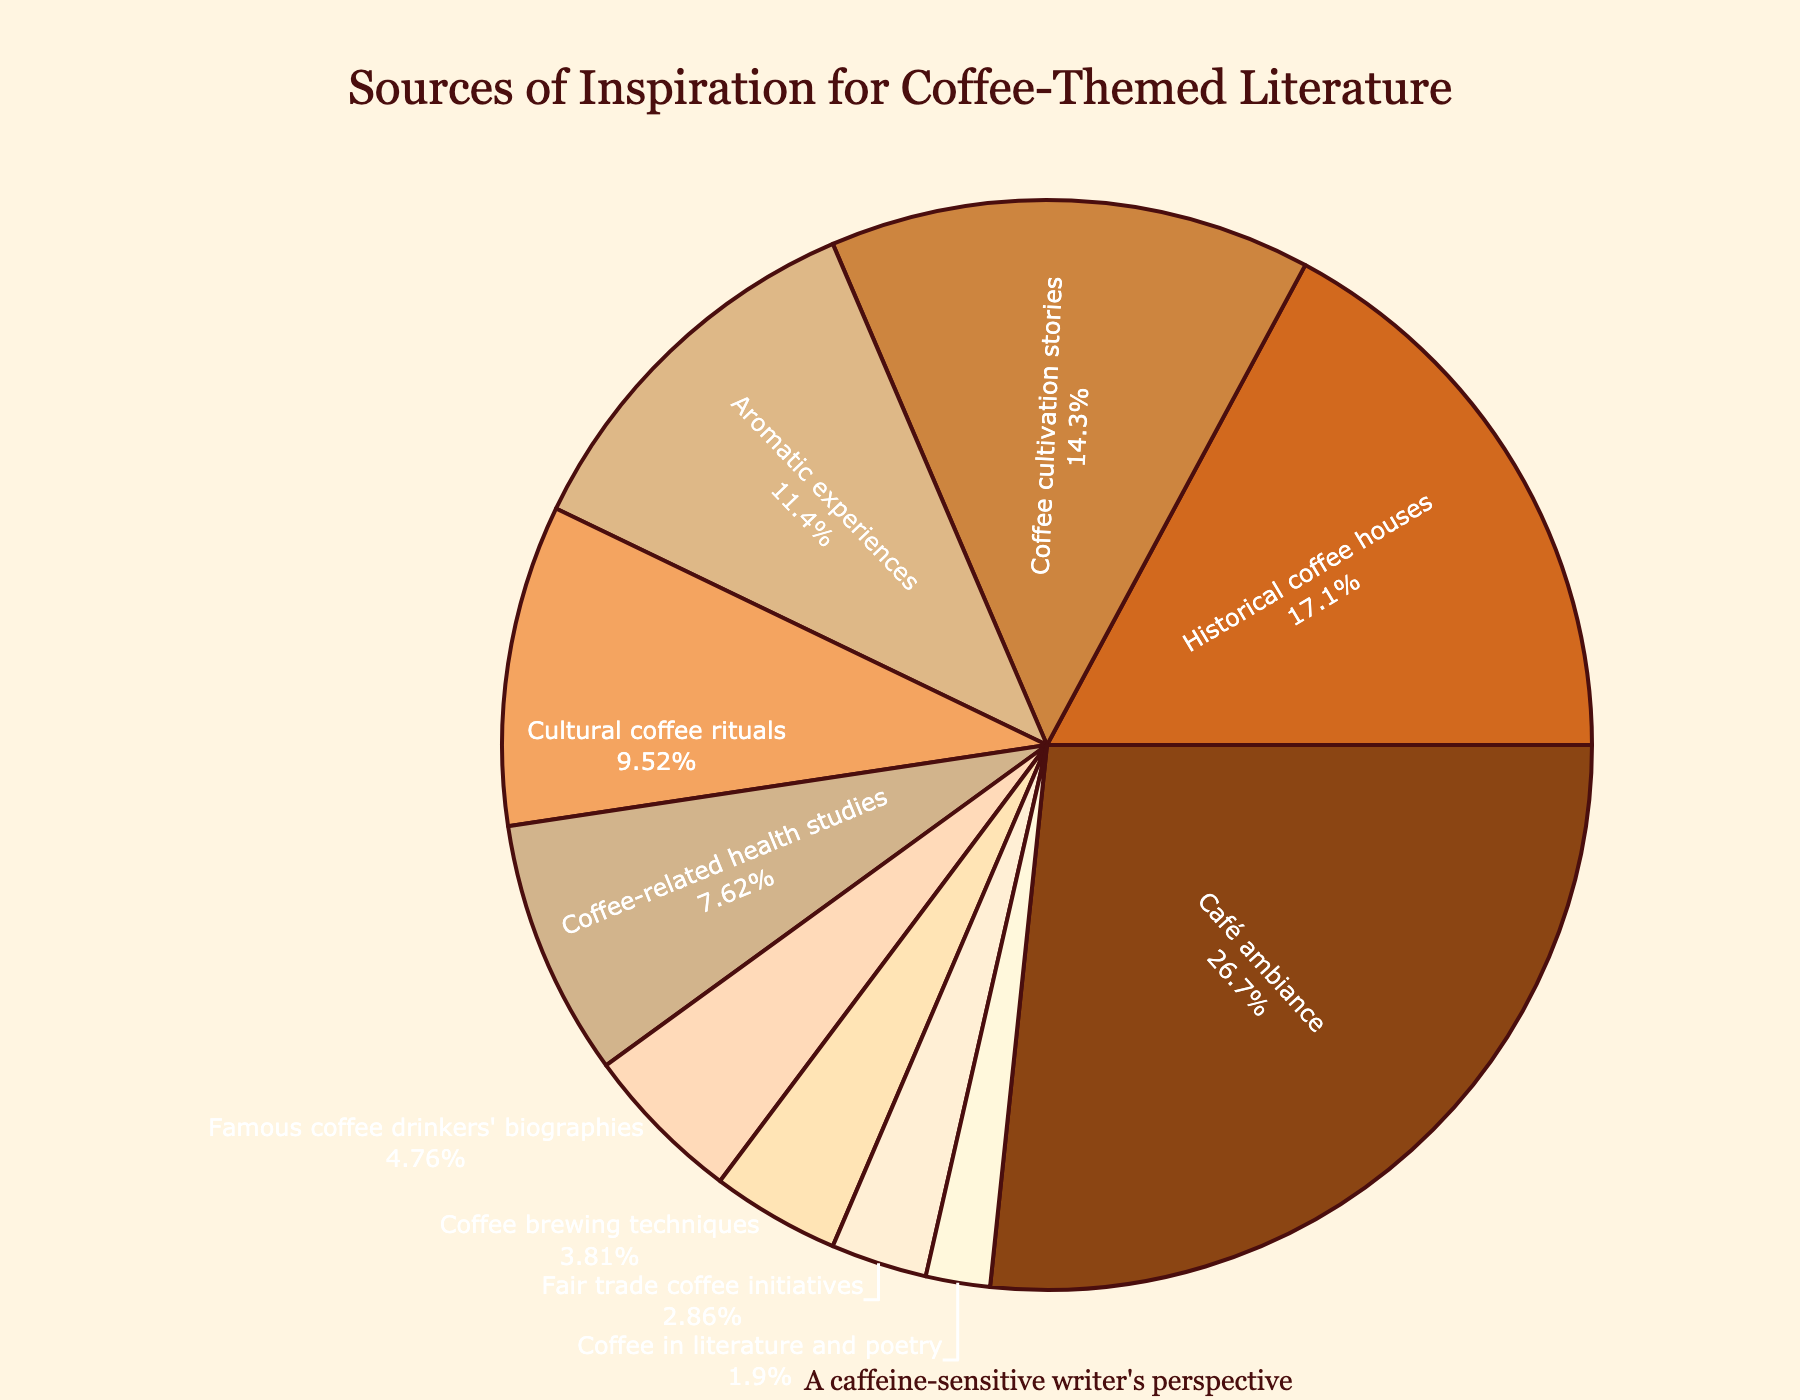What is the source with the highest percentage of inspiration? Identify the largest segment in the pie chart, which visually represents the largest percentage. The Café ambiance section is the largest segment.
Answer: Café ambiance What are the three smallest sources of inspiration? Identify the three smallest segments in the pie chart, judged by the smallest percentages. These segments are Fair trade coffee initiatives, Coffee in literature and poetry, and Coffee brewing techniques.
Answer: Fair trade coffee initiatives, Coffee in literature and poetry, Coffee brewing techniques What's the combined percentage of Cultural coffee rituals and Coffee-related health studies? Look at the percentages for Cultural coffee rituals (10%) and Coffee-related health studies (8%), and add them together. 10% + 8% = 18%
Answer: 18% How much larger is the percentage of Café ambiance compared to Aromatic experiences? Find the difference between the café ambiance (28%) and aromatic experiences (12%) by subtracting the smaller percentage from the larger one. 28% - 12% = 16%
Answer: 16% Which sources have a percentage greater than 10%? Identify segments in the pie chart with percentages over 10%. These include Café ambiance (28%), Historical coffee houses (18%), Coffee cultivation stories (15%), and Aromatic experiences (12%).
Answer: Café ambiance, Historical coffee houses, Coffee cultivation stories, Aromatic experiences What is the combined percentage for Coffee cultivation stories, Coffee-related health studies, and Famous coffee drinkers' biographies? Sum the percentages for Coffee cultivation stories (15%), Coffee-related health studies (8%), and Famous coffee drinkers' biographies (5%). 15% + 8% + 5% = 28%
Answer: 28% What is the visual color of the section representing Historical coffee houses? Look at the color assigned to the "Historical coffee houses" segment in the pie chart. This section is visually represented in dark brown.
Answer: Dark brown Which source represents 3% of inspiration? Identify the segment in the pie chart labeled as 3%. The pie chart shows this percentage for "Fair trade coffee initiatives."
Answer: Fair trade coffee initiatives 